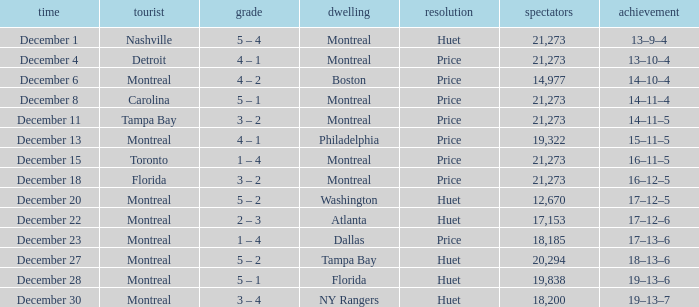What is the score when Philadelphia is at home? 4 – 1. 